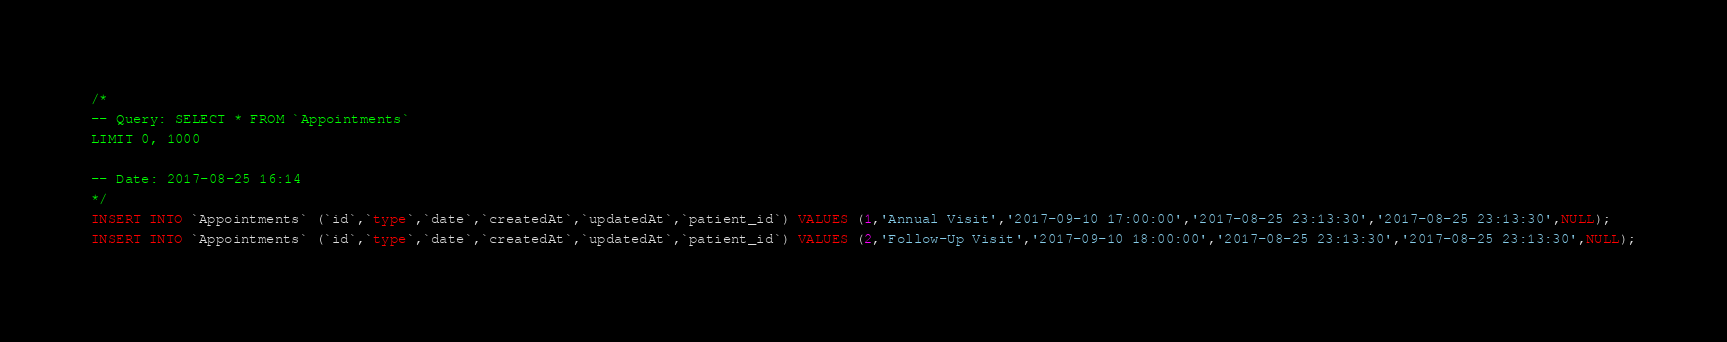Convert code to text. <code><loc_0><loc_0><loc_500><loc_500><_SQL_>/*
-- Query: SELECT * FROM `Appointments`
LIMIT 0, 1000

-- Date: 2017-08-25 16:14
*/
INSERT INTO `Appointments` (`id`,`type`,`date`,`createdAt`,`updatedAt`,`patient_id`) VALUES (1,'Annual Visit','2017-09-10 17:00:00','2017-08-25 23:13:30','2017-08-25 23:13:30',NULL);
INSERT INTO `Appointments` (`id`,`type`,`date`,`createdAt`,`updatedAt`,`patient_id`) VALUES (2,'Follow-Up Visit','2017-09-10 18:00:00','2017-08-25 23:13:30','2017-08-25 23:13:30',NULL);
</code> 